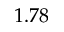<formula> <loc_0><loc_0><loc_500><loc_500>1 . 7 8</formula> 